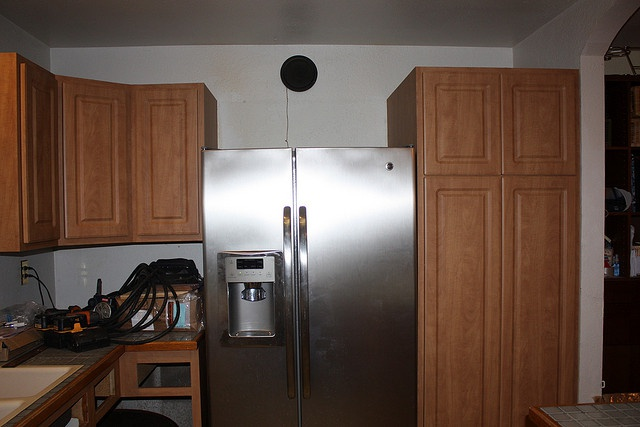Describe the objects in this image and their specific colors. I can see refrigerator in black, white, gray, and darkgray tones, sink in black, gray, and brown tones, and clock in black, gray, and darkgray tones in this image. 